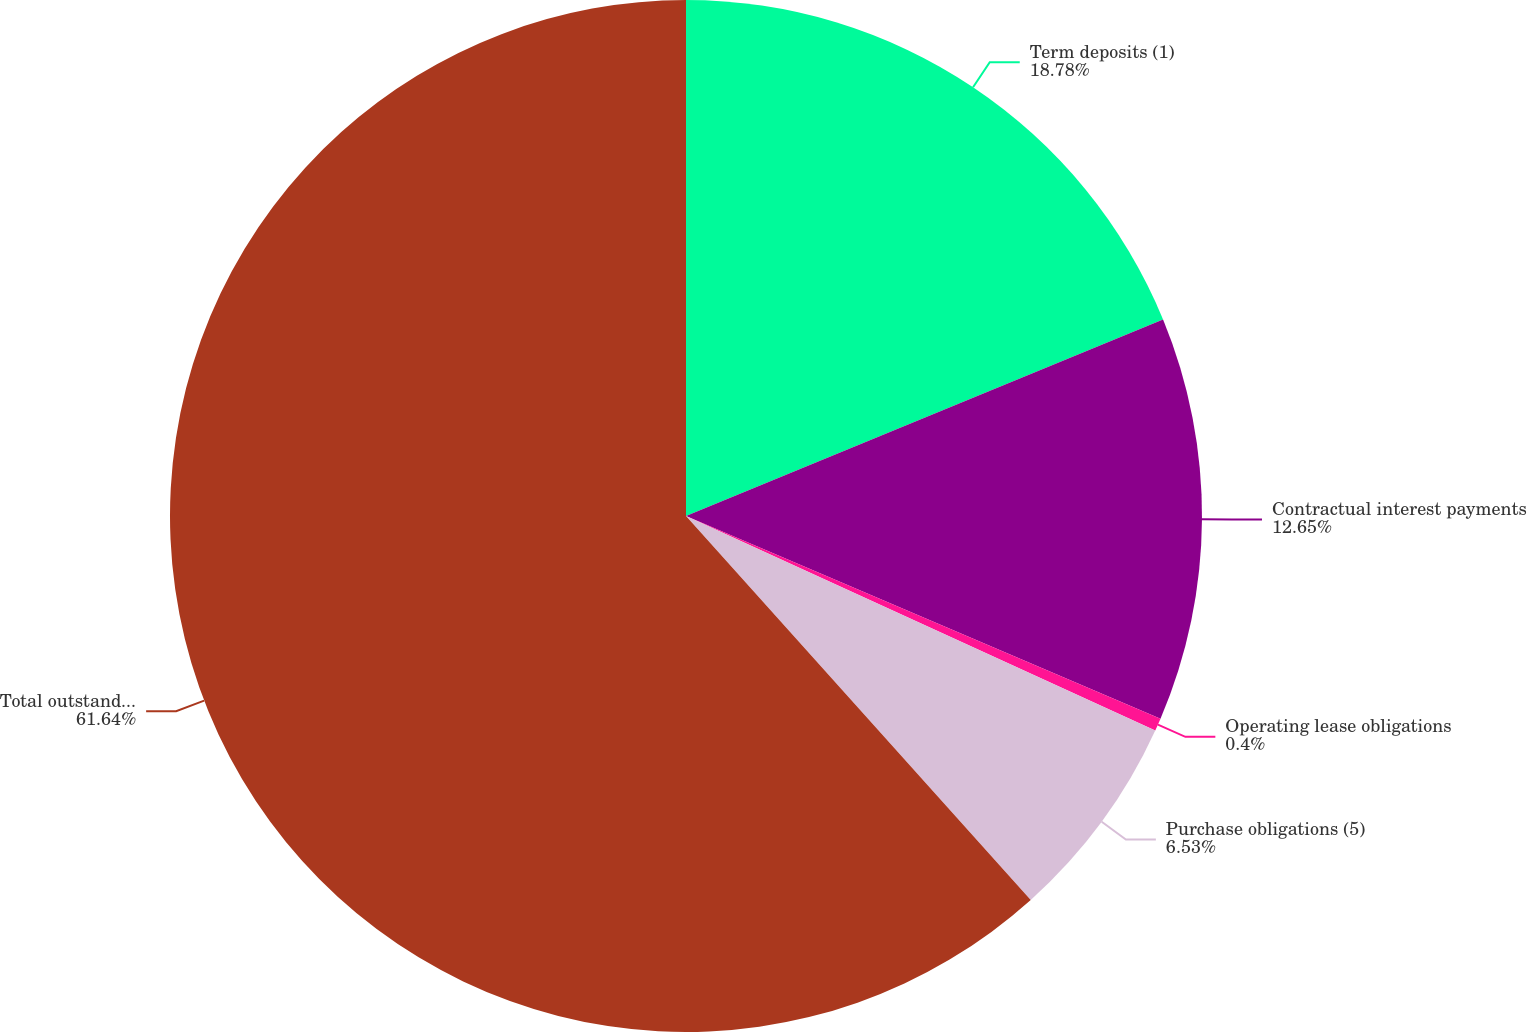Convert chart to OTSL. <chart><loc_0><loc_0><loc_500><loc_500><pie_chart><fcel>Term deposits (1)<fcel>Contractual interest payments<fcel>Operating lease obligations<fcel>Purchase obligations (5)<fcel>Total outstanding contractual<nl><fcel>18.78%<fcel>12.65%<fcel>0.4%<fcel>6.53%<fcel>61.65%<nl></chart> 